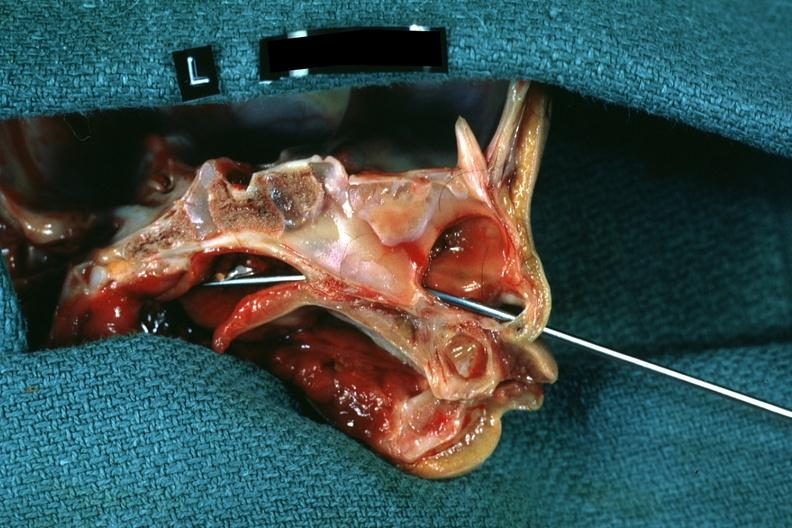was side showing patency right side not patent?
Answer the question using a single word or phrase. Yes 